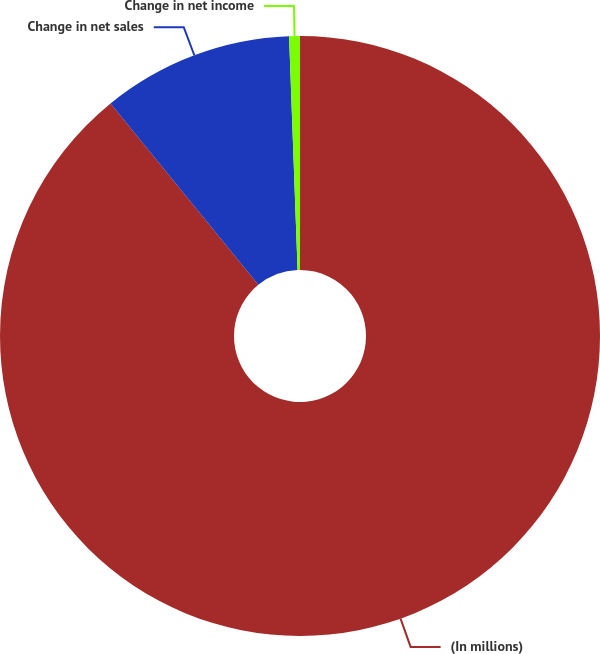Convert chart to OTSL. <chart><loc_0><loc_0><loc_500><loc_500><pie_chart><fcel>(In millions)<fcel>Change in net sales<fcel>Change in net income<nl><fcel>89.12%<fcel>10.3%<fcel>0.58%<nl></chart> 